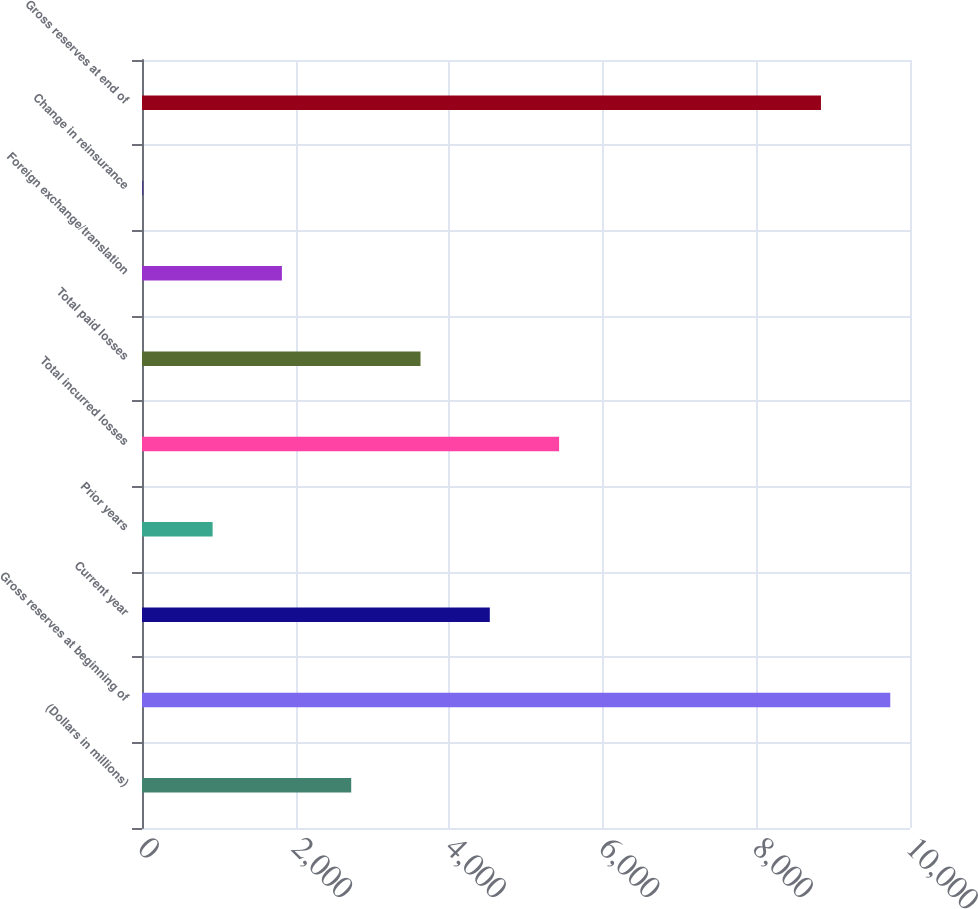Convert chart to OTSL. <chart><loc_0><loc_0><loc_500><loc_500><bar_chart><fcel>(Dollars in millions)<fcel>Gross reserves at beginning of<fcel>Current year<fcel>Prior years<fcel>Total incurred losses<fcel>Total paid losses<fcel>Foreign exchange/translation<fcel>Change in reinsurance<fcel>Gross reserves at end of<nl><fcel>2724.08<fcel>9743.06<fcel>4528.8<fcel>919.36<fcel>5431.16<fcel>3626.44<fcel>1821.72<fcel>17<fcel>8840.7<nl></chart> 